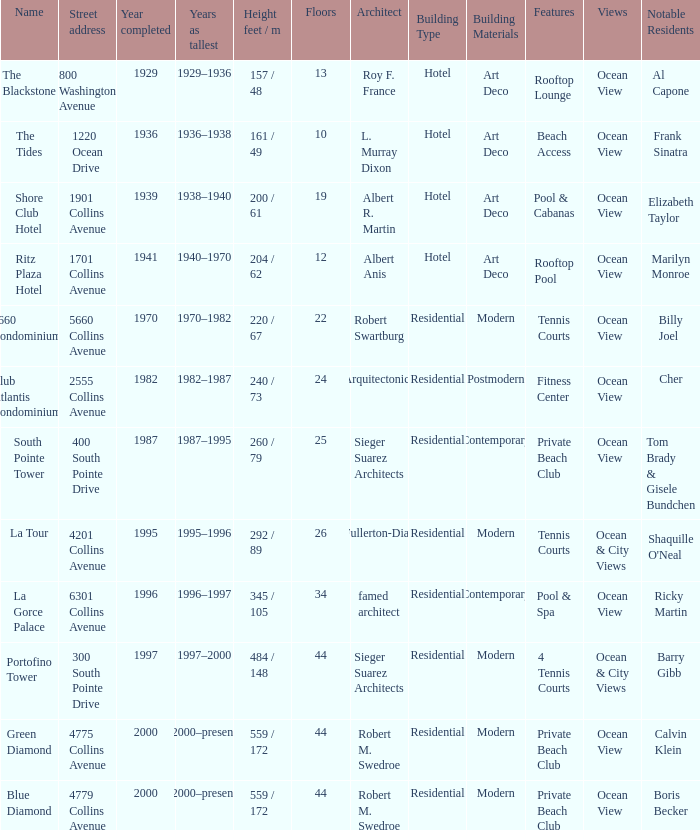How many floors does the Blue Diamond have? 44.0. 